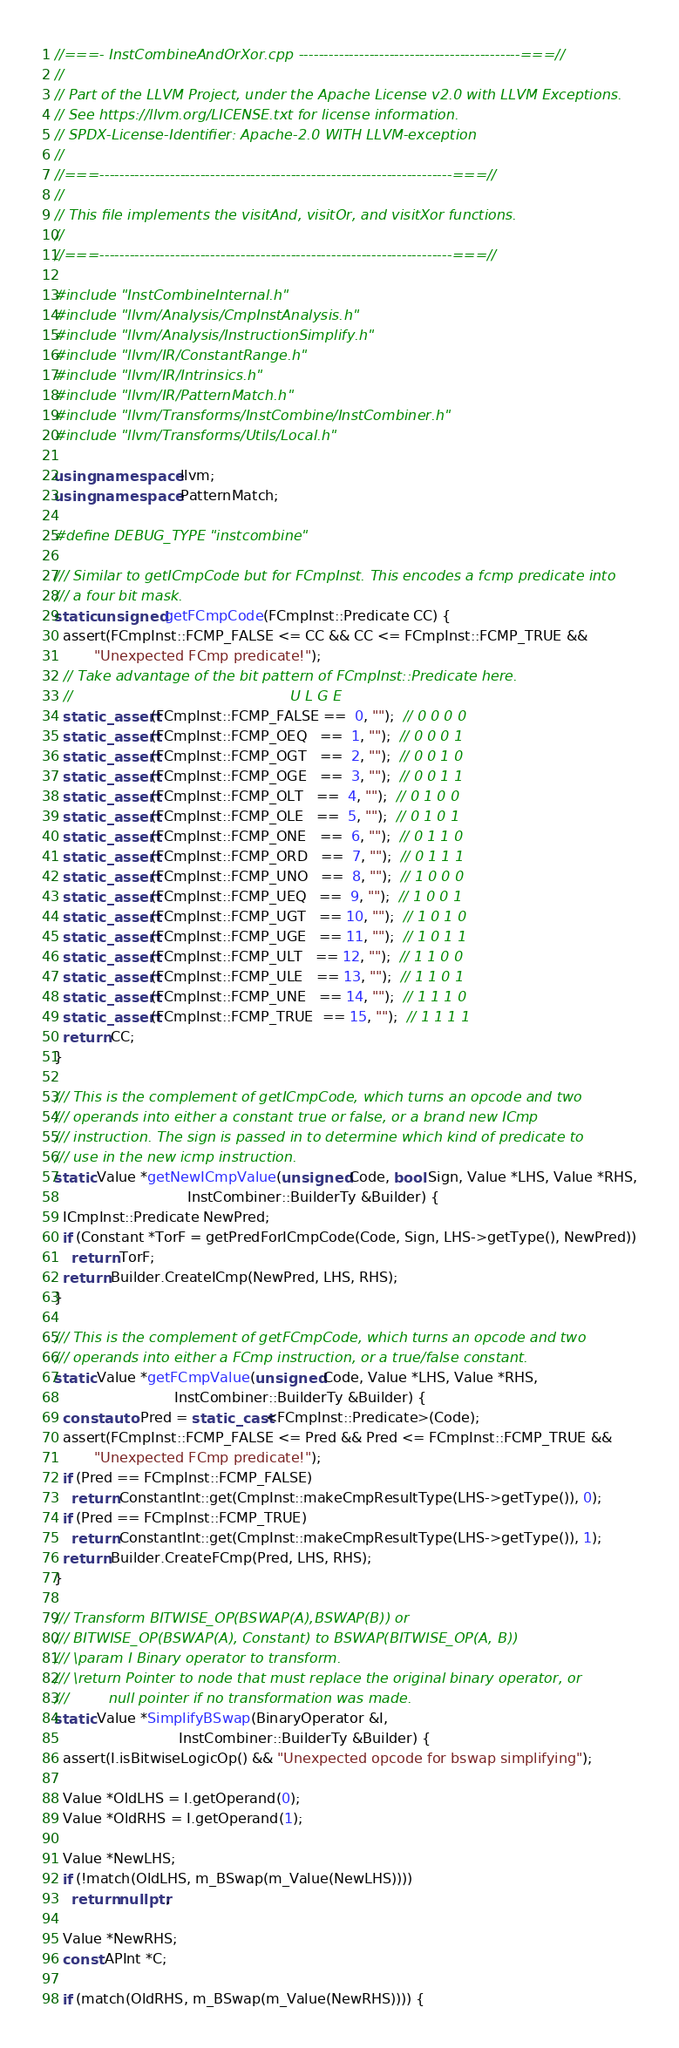<code> <loc_0><loc_0><loc_500><loc_500><_C++_>//===- InstCombineAndOrXor.cpp --------------------------------------------===//
//
// Part of the LLVM Project, under the Apache License v2.0 with LLVM Exceptions.
// See https://llvm.org/LICENSE.txt for license information.
// SPDX-License-Identifier: Apache-2.0 WITH LLVM-exception
//
//===----------------------------------------------------------------------===//
//
// This file implements the visitAnd, visitOr, and visitXor functions.
//
//===----------------------------------------------------------------------===//

#include "InstCombineInternal.h"
#include "llvm/Analysis/CmpInstAnalysis.h"
#include "llvm/Analysis/InstructionSimplify.h"
#include "llvm/IR/ConstantRange.h"
#include "llvm/IR/Intrinsics.h"
#include "llvm/IR/PatternMatch.h"
#include "llvm/Transforms/InstCombine/InstCombiner.h"
#include "llvm/Transforms/Utils/Local.h"

using namespace llvm;
using namespace PatternMatch;

#define DEBUG_TYPE "instcombine"

/// Similar to getICmpCode but for FCmpInst. This encodes a fcmp predicate into
/// a four bit mask.
static unsigned getFCmpCode(FCmpInst::Predicate CC) {
  assert(FCmpInst::FCMP_FALSE <= CC && CC <= FCmpInst::FCMP_TRUE &&
         "Unexpected FCmp predicate!");
  // Take advantage of the bit pattern of FCmpInst::Predicate here.
  //                                                 U L G E
  static_assert(FCmpInst::FCMP_FALSE ==  0, "");  // 0 0 0 0
  static_assert(FCmpInst::FCMP_OEQ   ==  1, "");  // 0 0 0 1
  static_assert(FCmpInst::FCMP_OGT   ==  2, "");  // 0 0 1 0
  static_assert(FCmpInst::FCMP_OGE   ==  3, "");  // 0 0 1 1
  static_assert(FCmpInst::FCMP_OLT   ==  4, "");  // 0 1 0 0
  static_assert(FCmpInst::FCMP_OLE   ==  5, "");  // 0 1 0 1
  static_assert(FCmpInst::FCMP_ONE   ==  6, "");  // 0 1 1 0
  static_assert(FCmpInst::FCMP_ORD   ==  7, "");  // 0 1 1 1
  static_assert(FCmpInst::FCMP_UNO   ==  8, "");  // 1 0 0 0
  static_assert(FCmpInst::FCMP_UEQ   ==  9, "");  // 1 0 0 1
  static_assert(FCmpInst::FCMP_UGT   == 10, "");  // 1 0 1 0
  static_assert(FCmpInst::FCMP_UGE   == 11, "");  // 1 0 1 1
  static_assert(FCmpInst::FCMP_ULT   == 12, "");  // 1 1 0 0
  static_assert(FCmpInst::FCMP_ULE   == 13, "");  // 1 1 0 1
  static_assert(FCmpInst::FCMP_UNE   == 14, "");  // 1 1 1 0
  static_assert(FCmpInst::FCMP_TRUE  == 15, "");  // 1 1 1 1
  return CC;
}

/// This is the complement of getICmpCode, which turns an opcode and two
/// operands into either a constant true or false, or a brand new ICmp
/// instruction. The sign is passed in to determine which kind of predicate to
/// use in the new icmp instruction.
static Value *getNewICmpValue(unsigned Code, bool Sign, Value *LHS, Value *RHS,
                              InstCombiner::BuilderTy &Builder) {
  ICmpInst::Predicate NewPred;
  if (Constant *TorF = getPredForICmpCode(Code, Sign, LHS->getType(), NewPred))
    return TorF;
  return Builder.CreateICmp(NewPred, LHS, RHS);
}

/// This is the complement of getFCmpCode, which turns an opcode and two
/// operands into either a FCmp instruction, or a true/false constant.
static Value *getFCmpValue(unsigned Code, Value *LHS, Value *RHS,
                           InstCombiner::BuilderTy &Builder) {
  const auto Pred = static_cast<FCmpInst::Predicate>(Code);
  assert(FCmpInst::FCMP_FALSE <= Pred && Pred <= FCmpInst::FCMP_TRUE &&
         "Unexpected FCmp predicate!");
  if (Pred == FCmpInst::FCMP_FALSE)
    return ConstantInt::get(CmpInst::makeCmpResultType(LHS->getType()), 0);
  if (Pred == FCmpInst::FCMP_TRUE)
    return ConstantInt::get(CmpInst::makeCmpResultType(LHS->getType()), 1);
  return Builder.CreateFCmp(Pred, LHS, RHS);
}

/// Transform BITWISE_OP(BSWAP(A),BSWAP(B)) or
/// BITWISE_OP(BSWAP(A), Constant) to BSWAP(BITWISE_OP(A, B))
/// \param I Binary operator to transform.
/// \return Pointer to node that must replace the original binary operator, or
///         null pointer if no transformation was made.
static Value *SimplifyBSwap(BinaryOperator &I,
                            InstCombiner::BuilderTy &Builder) {
  assert(I.isBitwiseLogicOp() && "Unexpected opcode for bswap simplifying");

  Value *OldLHS = I.getOperand(0);
  Value *OldRHS = I.getOperand(1);

  Value *NewLHS;
  if (!match(OldLHS, m_BSwap(m_Value(NewLHS))))
    return nullptr;

  Value *NewRHS;
  const APInt *C;

  if (match(OldRHS, m_BSwap(m_Value(NewRHS)))) {</code> 